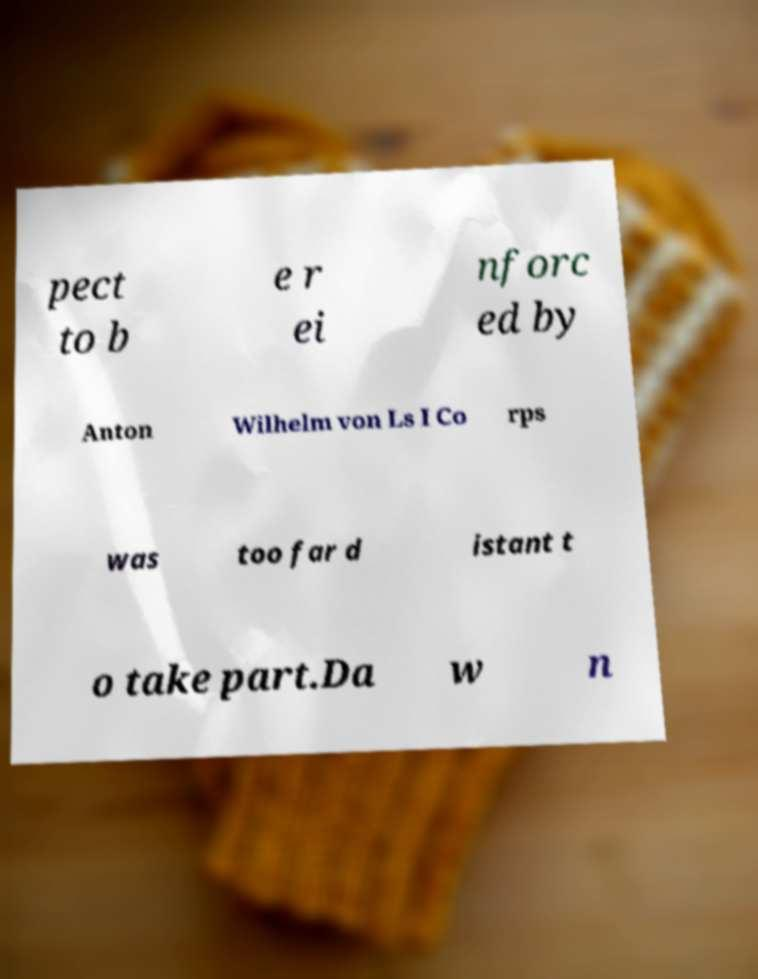Please read and relay the text visible in this image. What does it say? pect to b e r ei nforc ed by Anton Wilhelm von Ls I Co rps was too far d istant t o take part.Da w n 